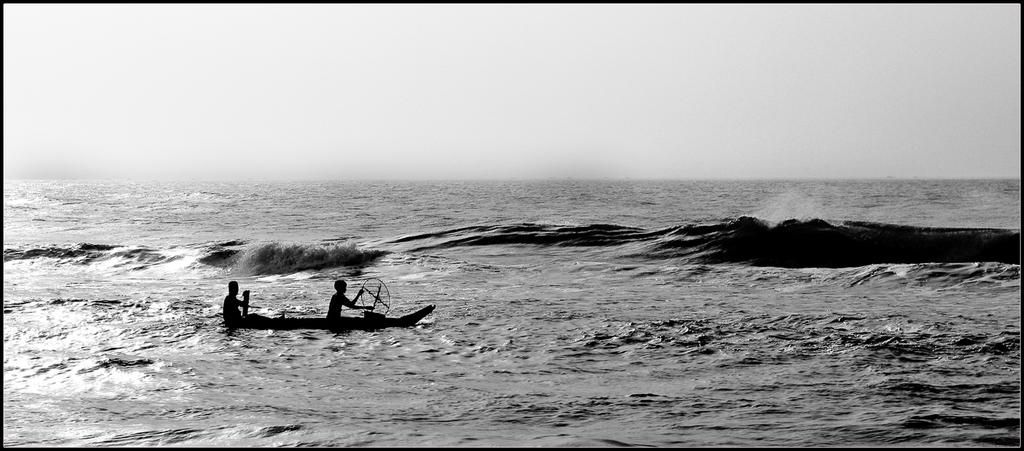What natural feature is present in the image? The image contains the sea. What specific aspect of the sea can be observed in the image? The tides of the sea are visible in the middle of the image. Are there any people in the image? Yes, there are two persons sitting on a boat. Where is the boat located in the image? The boat is visible on the sea. What is visible at the top of the image? The sky is visible at the top of the image. How many oranges are being used as a calculator in the image? There are no oranges or calculators present in the image. What number is being displayed on the oranges in the image? There are no oranges or numbers present in the image. 